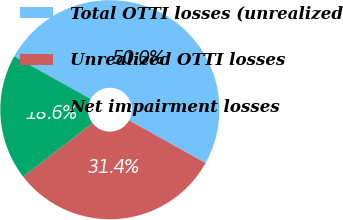<chart> <loc_0><loc_0><loc_500><loc_500><pie_chart><fcel>Total OTTI losses (unrealized<fcel>Unrealized OTTI losses<fcel>Net impairment losses<nl><fcel>50.0%<fcel>31.43%<fcel>18.57%<nl></chart> 